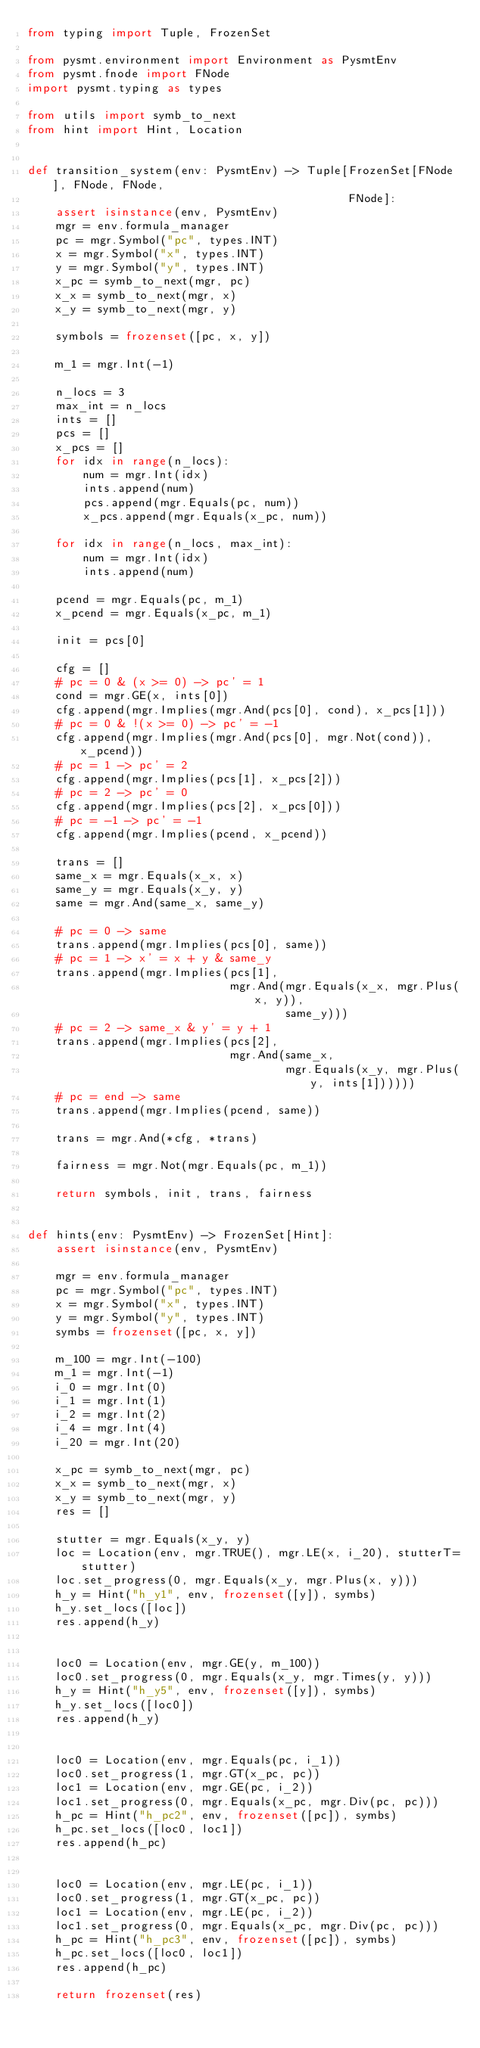Convert code to text. <code><loc_0><loc_0><loc_500><loc_500><_Python_>from typing import Tuple, FrozenSet

from pysmt.environment import Environment as PysmtEnv
from pysmt.fnode import FNode
import pysmt.typing as types

from utils import symb_to_next
from hint import Hint, Location


def transition_system(env: PysmtEnv) -> Tuple[FrozenSet[FNode], FNode, FNode,
                                              FNode]:
    assert isinstance(env, PysmtEnv)
    mgr = env.formula_manager
    pc = mgr.Symbol("pc", types.INT)
    x = mgr.Symbol("x", types.INT)
    y = mgr.Symbol("y", types.INT)
    x_pc = symb_to_next(mgr, pc)
    x_x = symb_to_next(mgr, x)
    x_y = symb_to_next(mgr, y)

    symbols = frozenset([pc, x, y])

    m_1 = mgr.Int(-1)

    n_locs = 3
    max_int = n_locs
    ints = []
    pcs = []
    x_pcs = []
    for idx in range(n_locs):
        num = mgr.Int(idx)
        ints.append(num)
        pcs.append(mgr.Equals(pc, num))
        x_pcs.append(mgr.Equals(x_pc, num))

    for idx in range(n_locs, max_int):
        num = mgr.Int(idx)
        ints.append(num)

    pcend = mgr.Equals(pc, m_1)
    x_pcend = mgr.Equals(x_pc, m_1)

    init = pcs[0]

    cfg = []
    # pc = 0 & (x >= 0) -> pc' = 1
    cond = mgr.GE(x, ints[0])
    cfg.append(mgr.Implies(mgr.And(pcs[0], cond), x_pcs[1]))
    # pc = 0 & !(x >= 0) -> pc' = -1
    cfg.append(mgr.Implies(mgr.And(pcs[0], mgr.Not(cond)), x_pcend))
    # pc = 1 -> pc' = 2
    cfg.append(mgr.Implies(pcs[1], x_pcs[2]))
    # pc = 2 -> pc' = 0
    cfg.append(mgr.Implies(pcs[2], x_pcs[0]))
    # pc = -1 -> pc' = -1
    cfg.append(mgr.Implies(pcend, x_pcend))

    trans = []
    same_x = mgr.Equals(x_x, x)
    same_y = mgr.Equals(x_y, y)
    same = mgr.And(same_x, same_y)

    # pc = 0 -> same
    trans.append(mgr.Implies(pcs[0], same))
    # pc = 1 -> x' = x + y & same_y
    trans.append(mgr.Implies(pcs[1],
                             mgr.And(mgr.Equals(x_x, mgr.Plus(x, y)),
                                     same_y)))
    # pc = 2 -> same_x & y' = y + 1
    trans.append(mgr.Implies(pcs[2],
                             mgr.And(same_x,
                                     mgr.Equals(x_y, mgr.Plus(y, ints[1])))))
    # pc = end -> same
    trans.append(mgr.Implies(pcend, same))

    trans = mgr.And(*cfg, *trans)

    fairness = mgr.Not(mgr.Equals(pc, m_1))

    return symbols, init, trans, fairness


def hints(env: PysmtEnv) -> FrozenSet[Hint]:
    assert isinstance(env, PysmtEnv)

    mgr = env.formula_manager
    pc = mgr.Symbol("pc", types.INT)
    x = mgr.Symbol("x", types.INT)
    y = mgr.Symbol("y", types.INT)
    symbs = frozenset([pc, x, y])

    m_100 = mgr.Int(-100)
    m_1 = mgr.Int(-1)
    i_0 = mgr.Int(0)
    i_1 = mgr.Int(1)
    i_2 = mgr.Int(2)
    i_4 = mgr.Int(4)
    i_20 = mgr.Int(20)

    x_pc = symb_to_next(mgr, pc)
    x_x = symb_to_next(mgr, x)
    x_y = symb_to_next(mgr, y)
    res = []

    stutter = mgr.Equals(x_y, y)
    loc = Location(env, mgr.TRUE(), mgr.LE(x, i_20), stutterT=stutter)
    loc.set_progress(0, mgr.Equals(x_y, mgr.Plus(x, y)))
    h_y = Hint("h_y1", env, frozenset([y]), symbs)
    h_y.set_locs([loc])
    res.append(h_y)


    loc0 = Location(env, mgr.GE(y, m_100))
    loc0.set_progress(0, mgr.Equals(x_y, mgr.Times(y, y)))
    h_y = Hint("h_y5", env, frozenset([y]), symbs)
    h_y.set_locs([loc0])
    res.append(h_y)


    loc0 = Location(env, mgr.Equals(pc, i_1))
    loc0.set_progress(1, mgr.GT(x_pc, pc))
    loc1 = Location(env, mgr.GE(pc, i_2))
    loc1.set_progress(0, mgr.Equals(x_pc, mgr.Div(pc, pc)))
    h_pc = Hint("h_pc2", env, frozenset([pc]), symbs)
    h_pc.set_locs([loc0, loc1])
    res.append(h_pc)


    loc0 = Location(env, mgr.LE(pc, i_1))
    loc0.set_progress(1, mgr.GT(x_pc, pc))
    loc1 = Location(env, mgr.LE(pc, i_2))
    loc1.set_progress(0, mgr.Equals(x_pc, mgr.Div(pc, pc)))
    h_pc = Hint("h_pc3", env, frozenset([pc]), symbs)
    h_pc.set_locs([loc0, loc1])
    res.append(h_pc)

    return frozenset(res)
</code> 